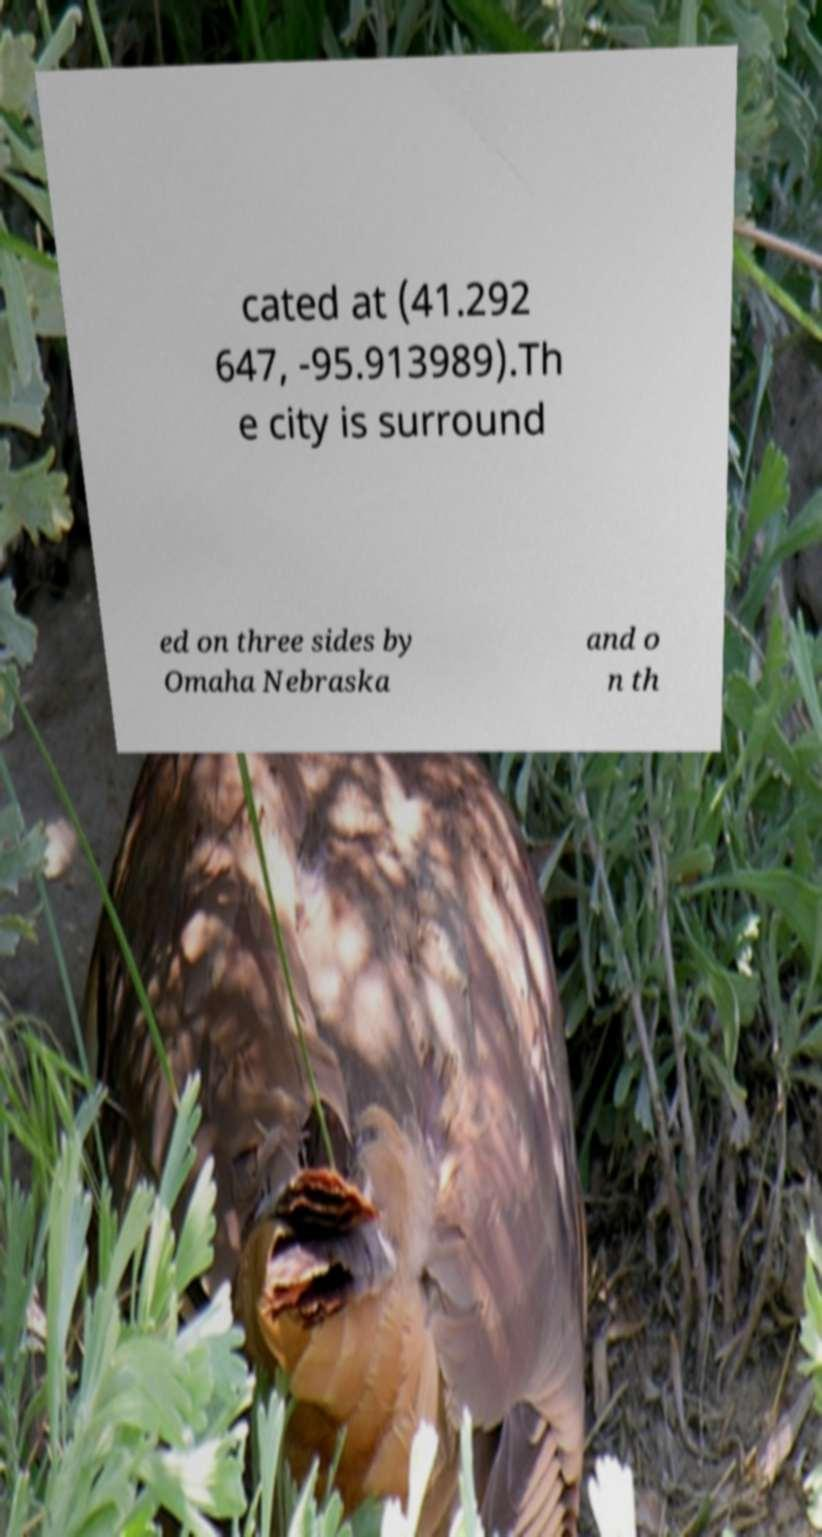Could you assist in decoding the text presented in this image and type it out clearly? cated at (41.292 647, -95.913989).Th e city is surround ed on three sides by Omaha Nebraska and o n th 